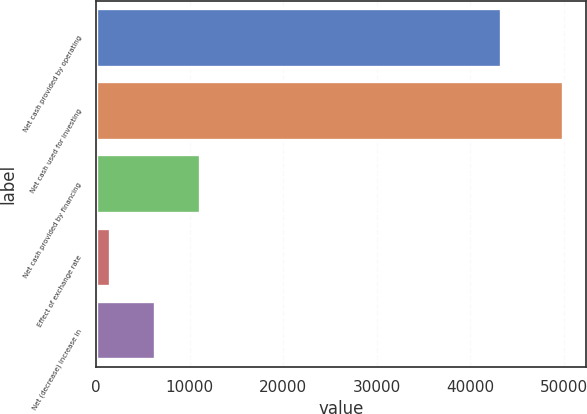Convert chart. <chart><loc_0><loc_0><loc_500><loc_500><bar_chart><fcel>Net cash provided by operating<fcel>Net cash used for investing<fcel>Net cash provided by financing<fcel>Effect of exchange rate<fcel>Net (decrease) increase in<nl><fcel>43290<fcel>49863<fcel>11144.6<fcel>1465<fcel>6304.8<nl></chart> 